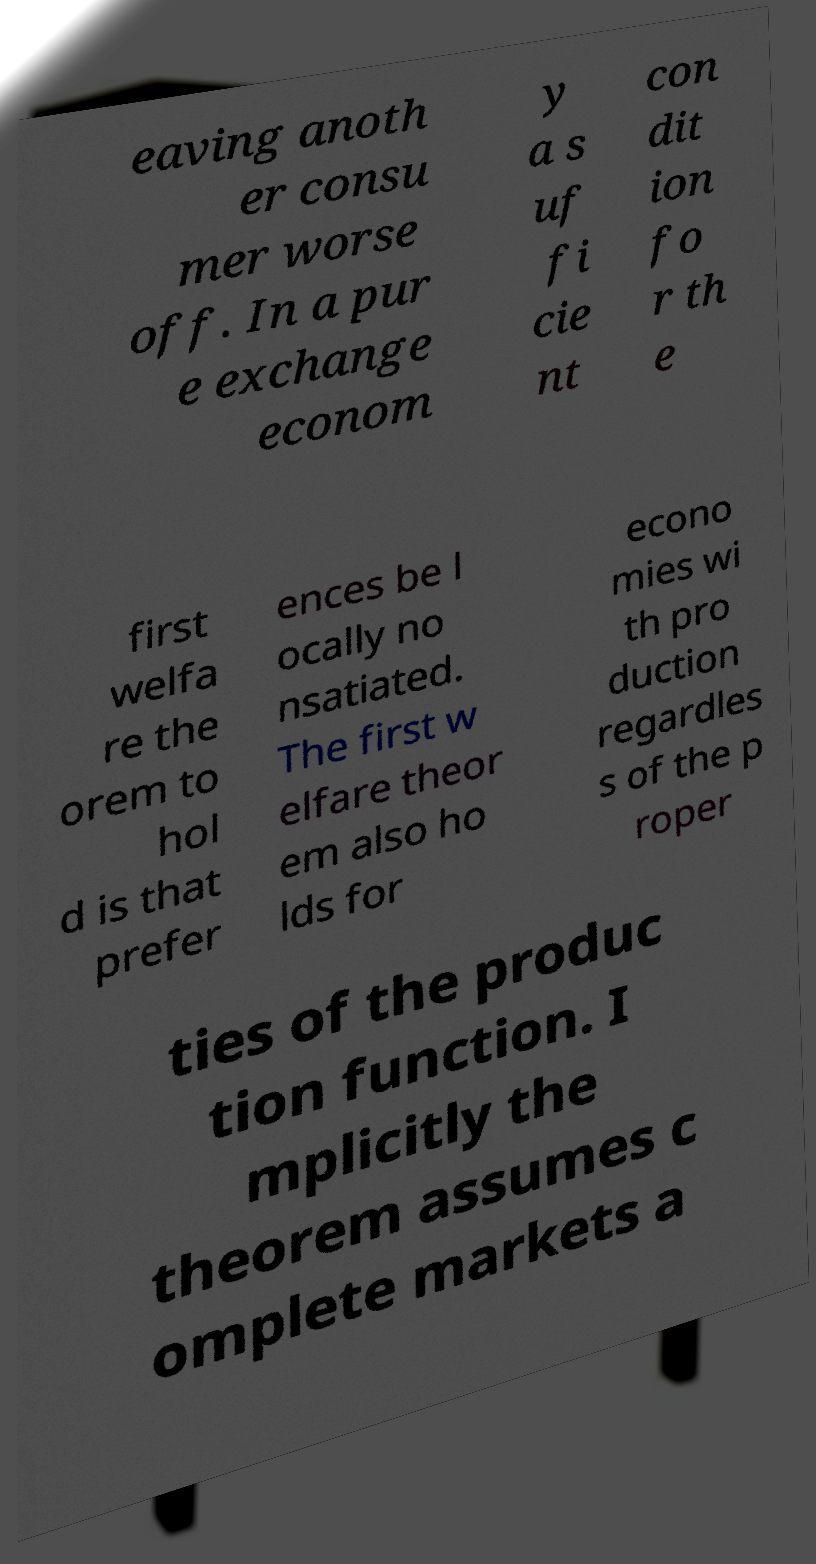For documentation purposes, I need the text within this image transcribed. Could you provide that? eaving anoth er consu mer worse off. In a pur e exchange econom y a s uf fi cie nt con dit ion fo r th e first welfa re the orem to hol d is that prefer ences be l ocally no nsatiated. The first w elfare theor em also ho lds for econo mies wi th pro duction regardles s of the p roper ties of the produc tion function. I mplicitly the theorem assumes c omplete markets a 